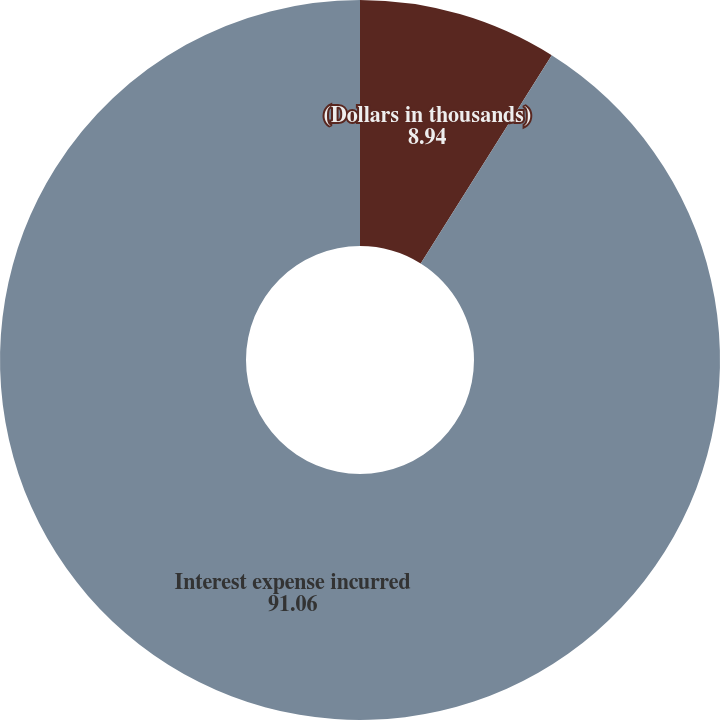<chart> <loc_0><loc_0><loc_500><loc_500><pie_chart><fcel>(Dollars in thousands)<fcel>Interest expense incurred<nl><fcel>8.94%<fcel>91.06%<nl></chart> 